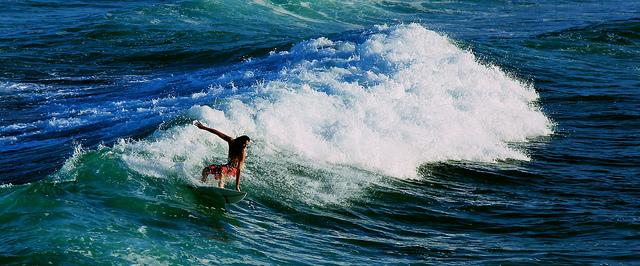Is this person afraid of water?
Answer briefly. No. What color is the foam?
Write a very short answer. White. What is this person doing?
Answer briefly. Surfing. What color is his suit?
Be succinct. Red. 